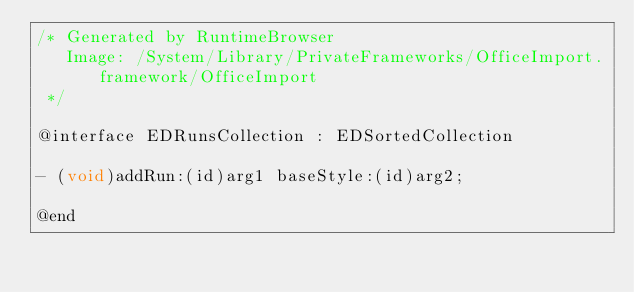Convert code to text. <code><loc_0><loc_0><loc_500><loc_500><_C_>/* Generated by RuntimeBrowser
   Image: /System/Library/PrivateFrameworks/OfficeImport.framework/OfficeImport
 */

@interface EDRunsCollection : EDSortedCollection

- (void)addRun:(id)arg1 baseStyle:(id)arg2;

@end
</code> 